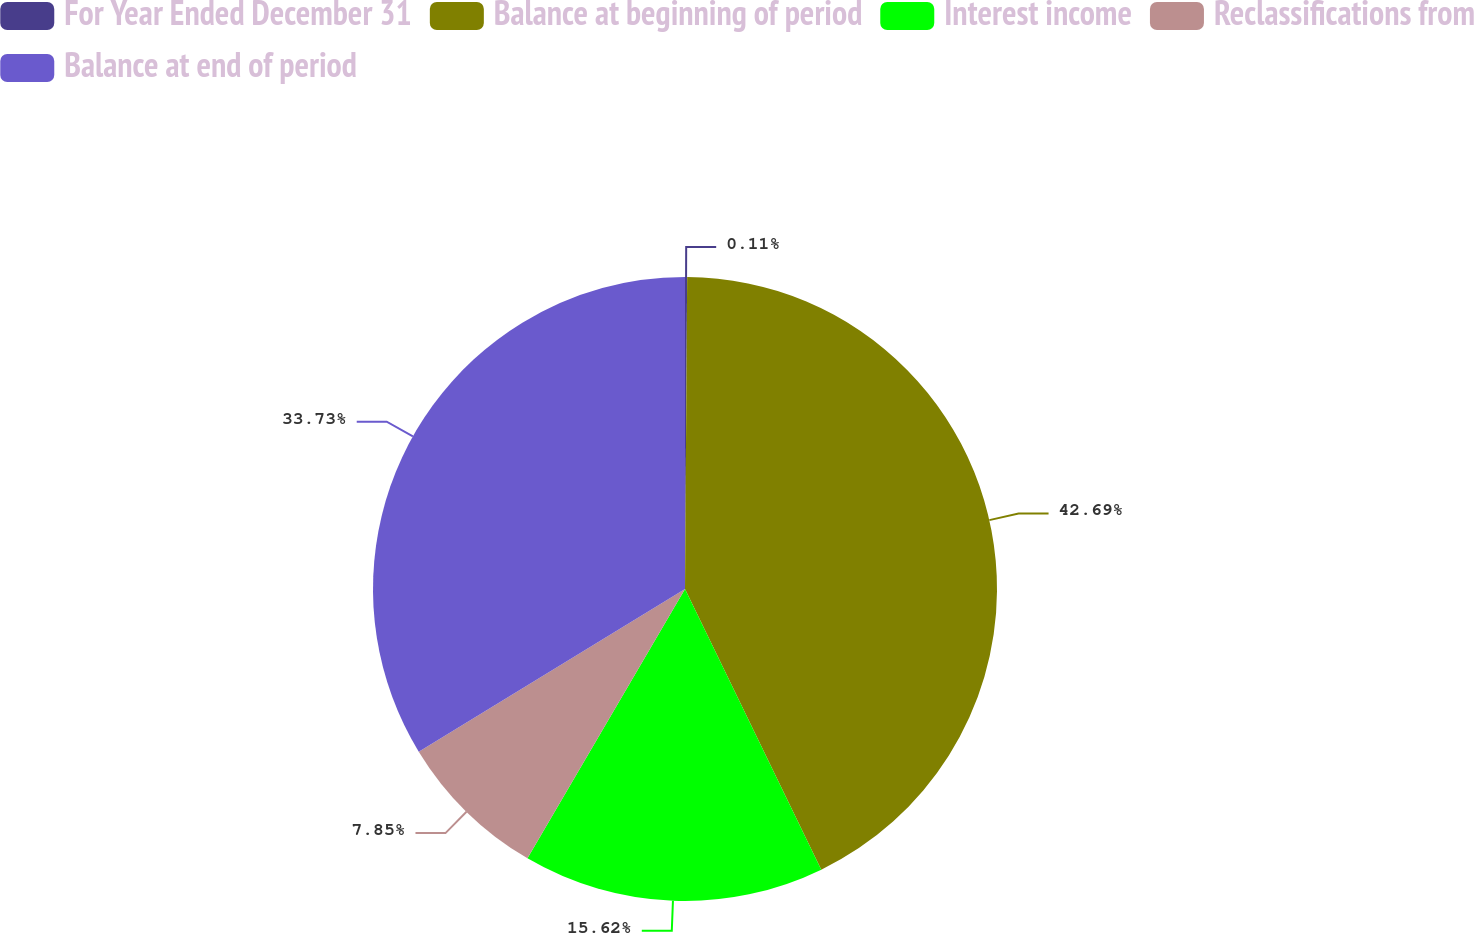Convert chart to OTSL. <chart><loc_0><loc_0><loc_500><loc_500><pie_chart><fcel>For Year Ended December 31<fcel>Balance at beginning of period<fcel>Interest income<fcel>Reclassifications from<fcel>Balance at end of period<nl><fcel>0.11%<fcel>42.7%<fcel>15.62%<fcel>7.85%<fcel>33.73%<nl></chart> 